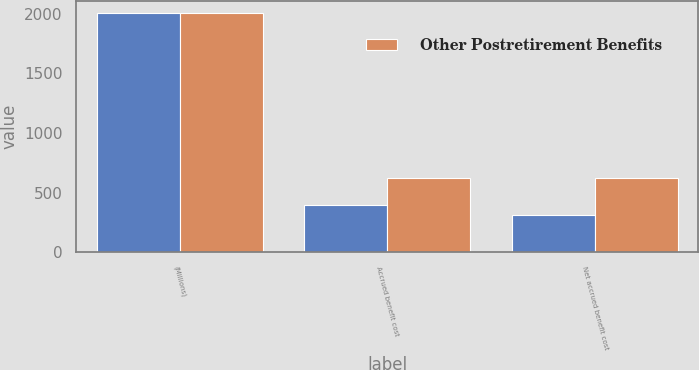<chart> <loc_0><loc_0><loc_500><loc_500><stacked_bar_chart><ecel><fcel>(Millions)<fcel>Accrued benefit cost<fcel>Net accrued benefit cost<nl><fcel>nan<fcel>2003<fcel>395<fcel>308<nl><fcel>Other Postretirement Benefits<fcel>2003<fcel>624<fcel>624<nl></chart> 